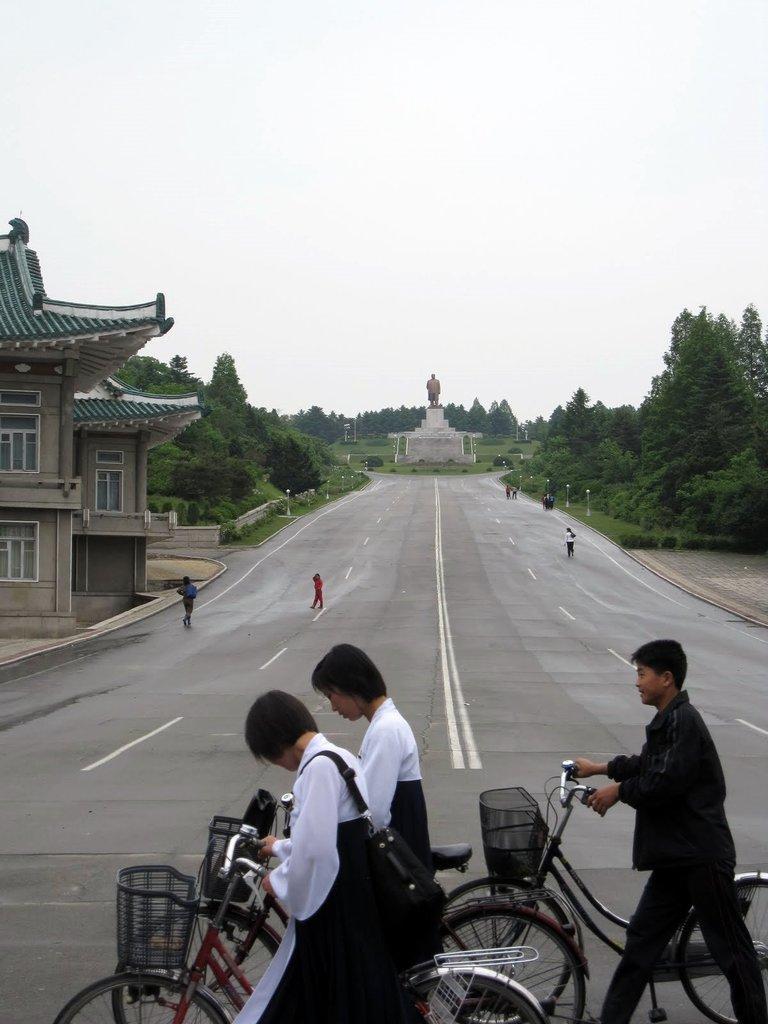Could you give a brief overview of what you see in this image? In this image I can see a road, on the road I can see few persons , in the foreground there are three persons holding bi-cycles walking on the road, there is a sculpture in the middle there are two houses and trees visible on the left side and some trees visible on right side , at the top there is the sky visible. 